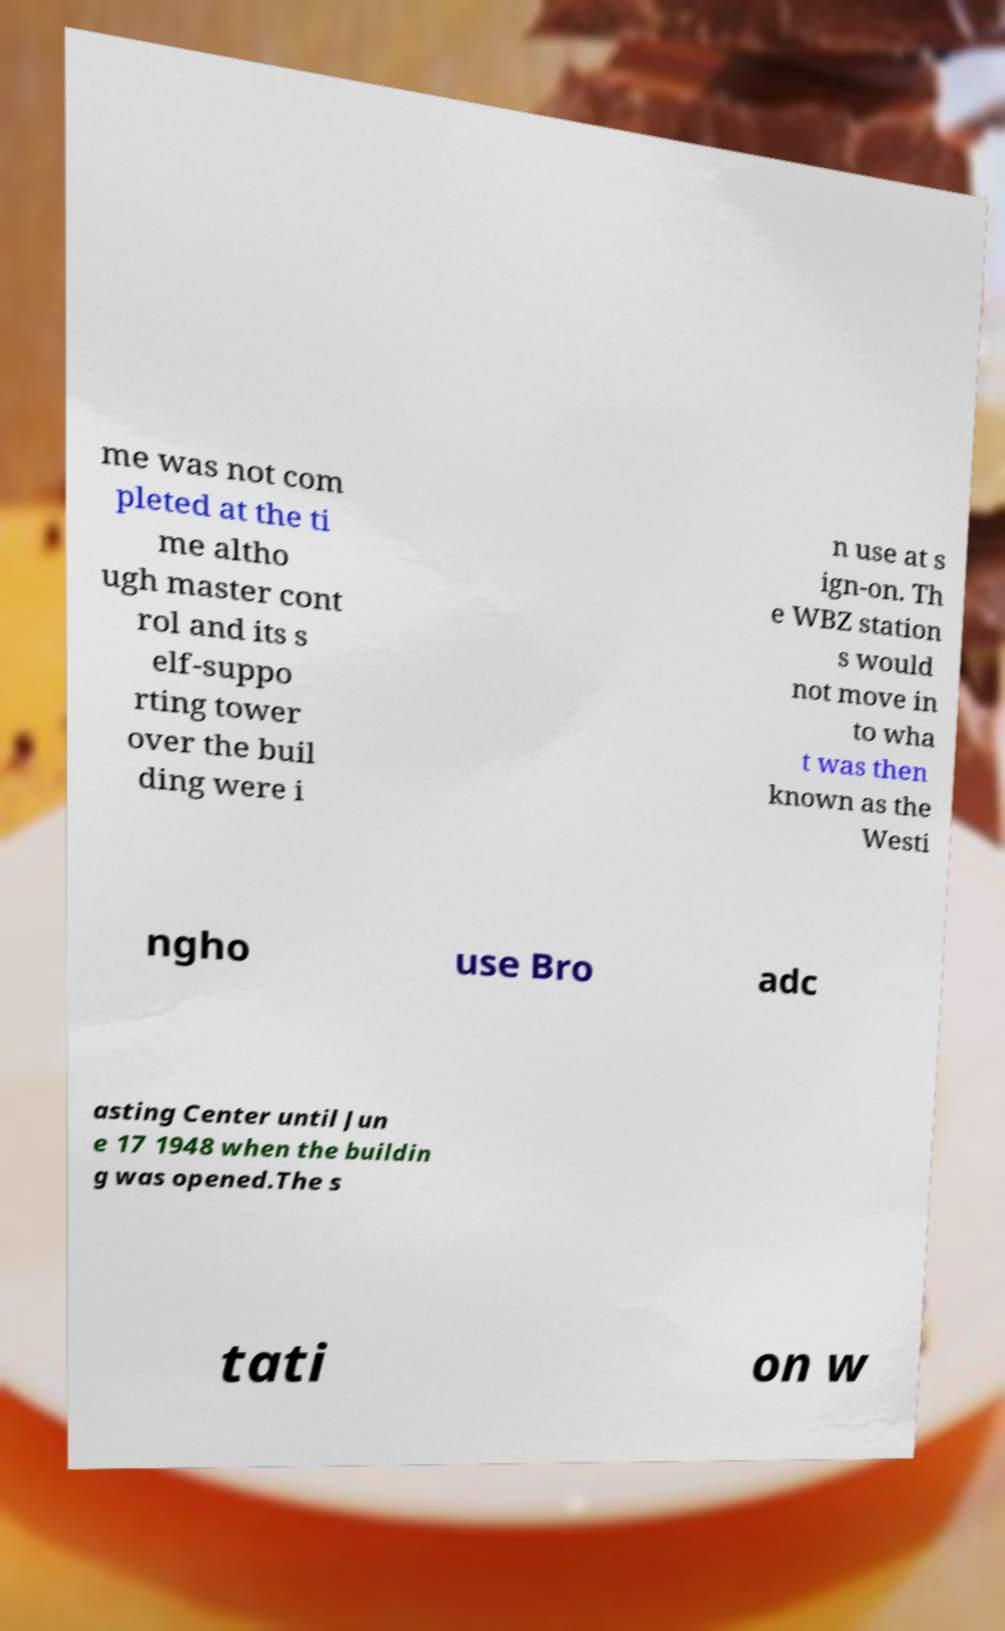Can you accurately transcribe the text from the provided image for me? me was not com pleted at the ti me altho ugh master cont rol and its s elf-suppo rting tower over the buil ding were i n use at s ign-on. Th e WBZ station s would not move in to wha t was then known as the Westi ngho use Bro adc asting Center until Jun e 17 1948 when the buildin g was opened.The s tati on w 